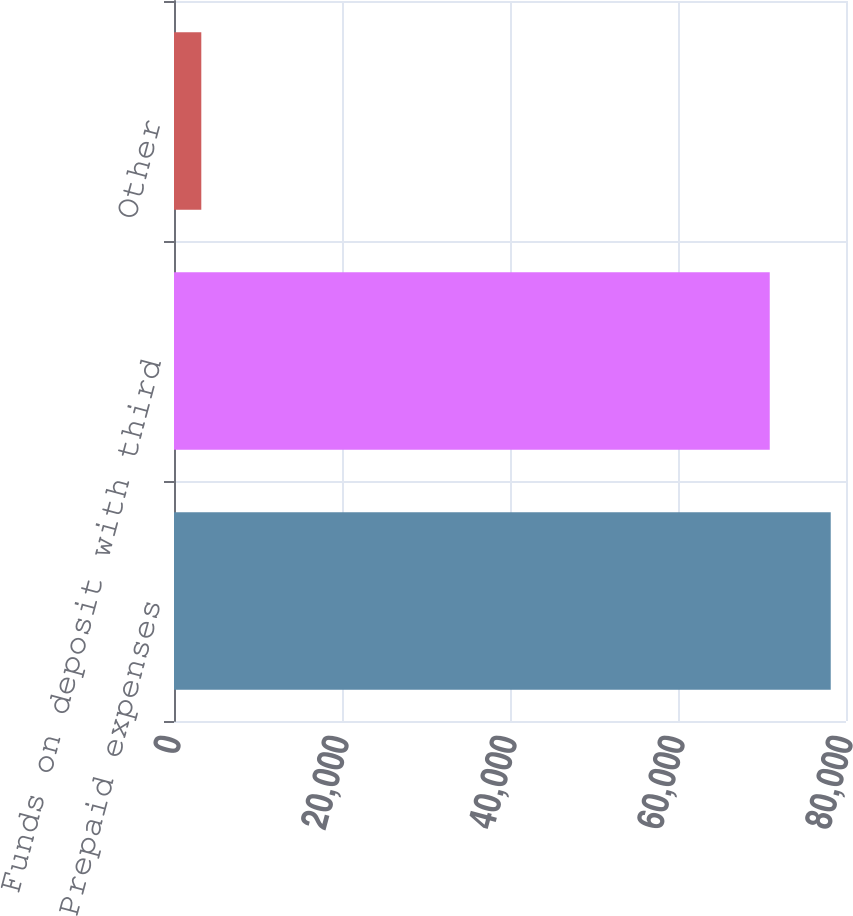Convert chart to OTSL. <chart><loc_0><loc_0><loc_500><loc_500><bar_chart><fcel>Prepaid expenses<fcel>Funds on deposit with third<fcel>Other<nl><fcel>78182.3<fcel>70922<fcel>3250<nl></chart> 